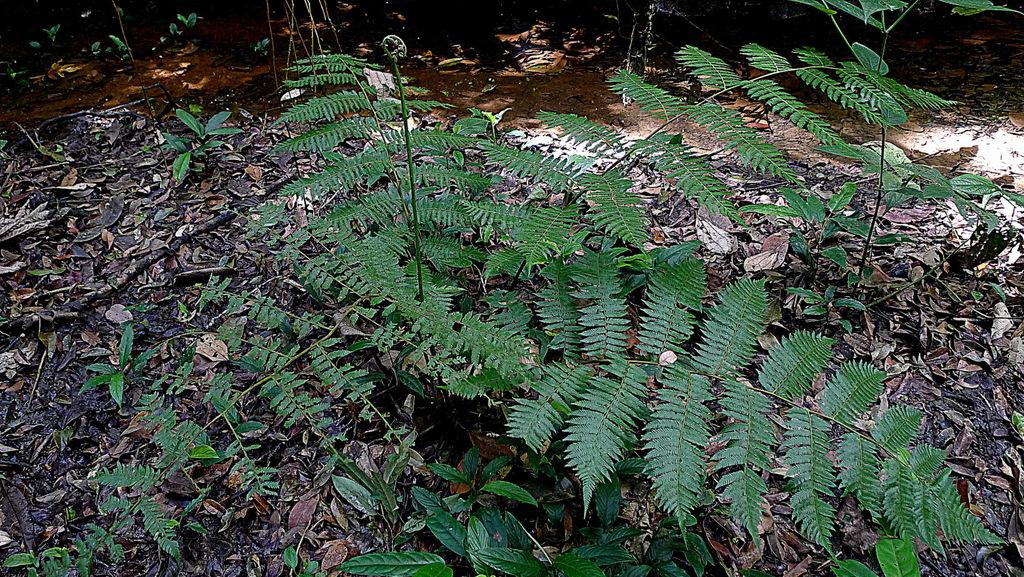What type of living organisms can be seen in the image? Plants can be seen in the image. What can be found on the ground in the image? There are leaves on the ground in the image. What type of arithmetic problem is being solved by the dog in the image? There is no dog or arithmetic problem present in the image. What brand of shoe can be seen in the image? There are no shoes present in the image. 